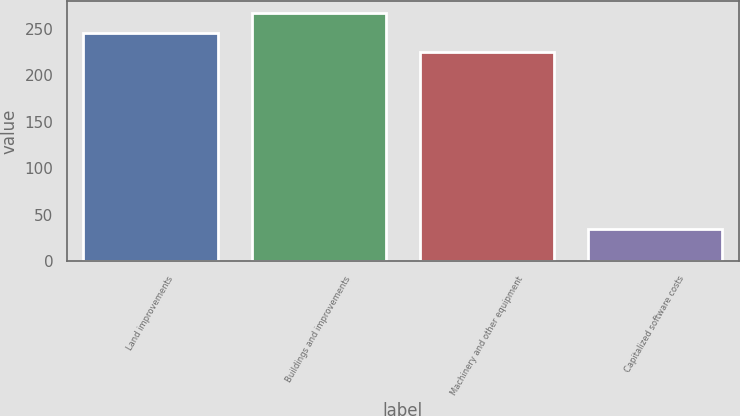Convert chart. <chart><loc_0><loc_0><loc_500><loc_500><bar_chart><fcel>Land improvements<fcel>Buildings and improvements<fcel>Machinery and other equipment<fcel>Capitalized software costs<nl><fcel>246<fcel>267<fcel>225<fcel>35<nl></chart> 